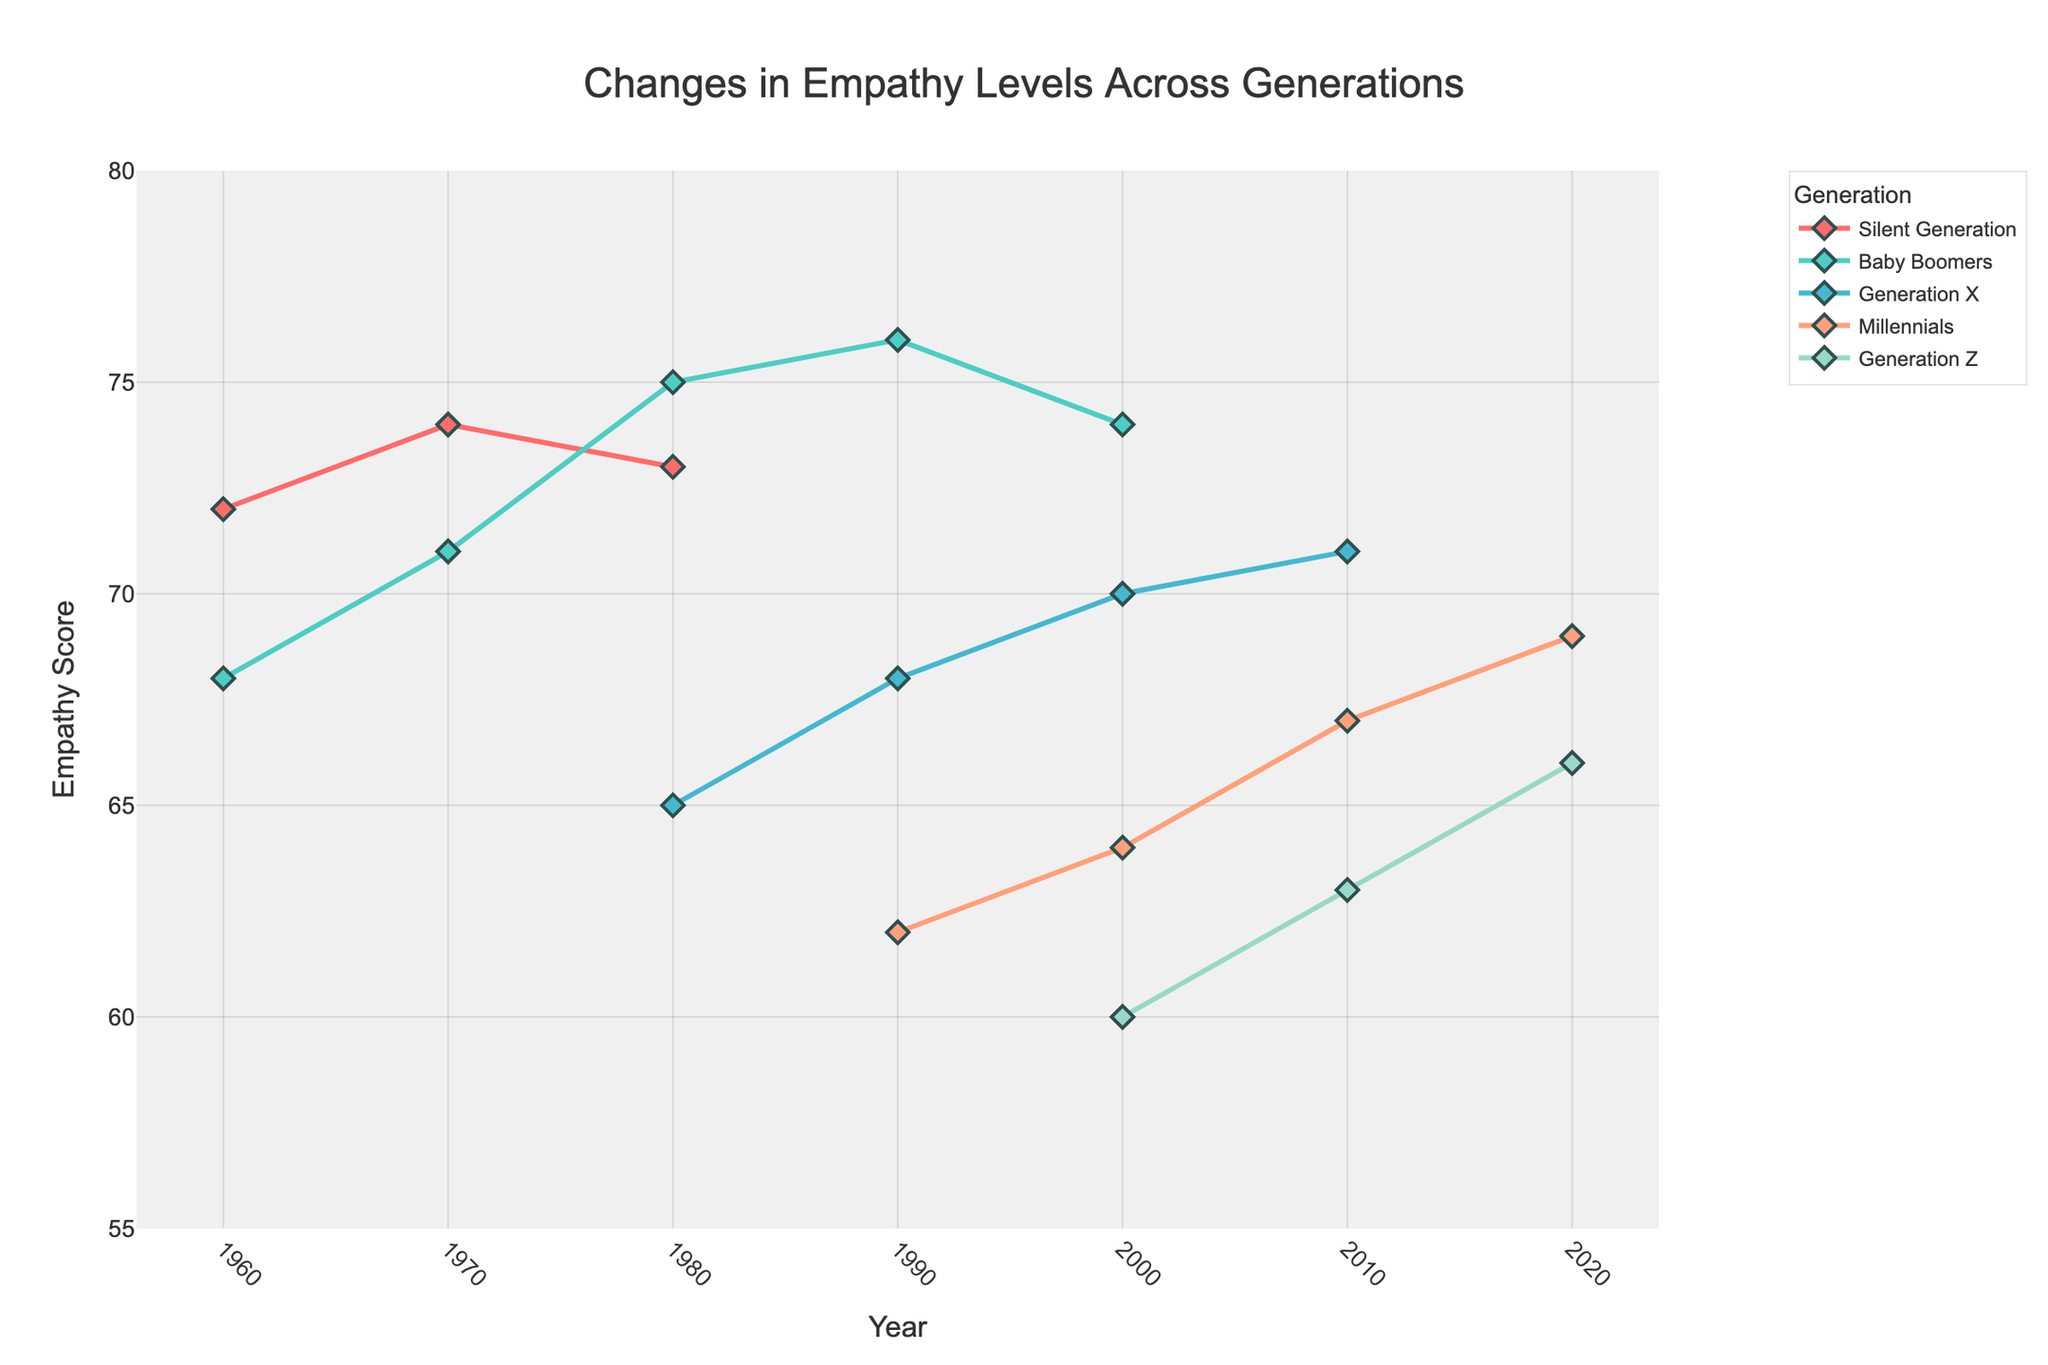What's the highest empathy score recorded for Baby Boomers? Referring to the chart, you can see the highest point for Baby Boomers. The peak for the Baby Boomers is in 1990, where the empathy score is 76.
Answer: 76 Which generation showed the lowest empathy score in 2000? By comparing all the empathy scores in the year 2000 among the different generations, Generation Z has the lowest empathy score at 60.
Answer: Generation Z How much did the empathy score for Generation X change from 2000 to 2010? In 2000, Generation X had an empathy score of 70, and by 2010, it increased to 71. The difference is 71 - 70 = 1.
Answer: 1 Which generation had the most significant increase in empathy from the 2000s to 2020s? Comparing the empathy scores for the different generations from 2000 to 2020, Millennials showed an increase from 64 to 69, representing the most significant rise of 5 points.
Answer: Millennials What is the range of empathy scores for the Silent Generation? The Silent Generation's empathy scores range from 72 (1960) to 74 (1970), giving a range calculation of 74 - 72 = 2.
Answer: 2 How do the empathy trends from 1960 to 2020 for Generation X compare with Baby Boomers? Generation X consistently showed lower empathy scores than Baby Boomers in every overlapping year. Baby Boomers scored from 68 to 76, while Generation X scored from 65 to 71 during their respective years.
Answer: Generation X consistently lower What is the average empathy score for Millennials over the observed years? Averaging the scores (62 in 1990, 64 in 2000, 67 in 2010, 69 in 2020) total is (62 + 64 + 67 + 69) = 262, divided by 4 is 262/4 = 65.5.
Answer: 65.5 Did any generation's empathy score decrease over time? Observing the lowest point compared to the highest for each generation, only the Silent Generation showed a slight decrease comparing any two years: from 74 in 1970 to 73 in 1980.
Answer: Silent Generation What is the median empathy score for Generation Z? The scores for Generation Z are 60 (2000), 63 (2010), 66 (2020). The median in an ordered series 60, 63, 66 is the middle value, which is 63.
Answer: 63 Which generation had the smallest variation in empathy scores? Observing the range of data, the Silent Generation shows the least variation from 72 to 74. The range is 74 - 72 = 2, the smallest variation among all generations.
Answer: Silent Generation 